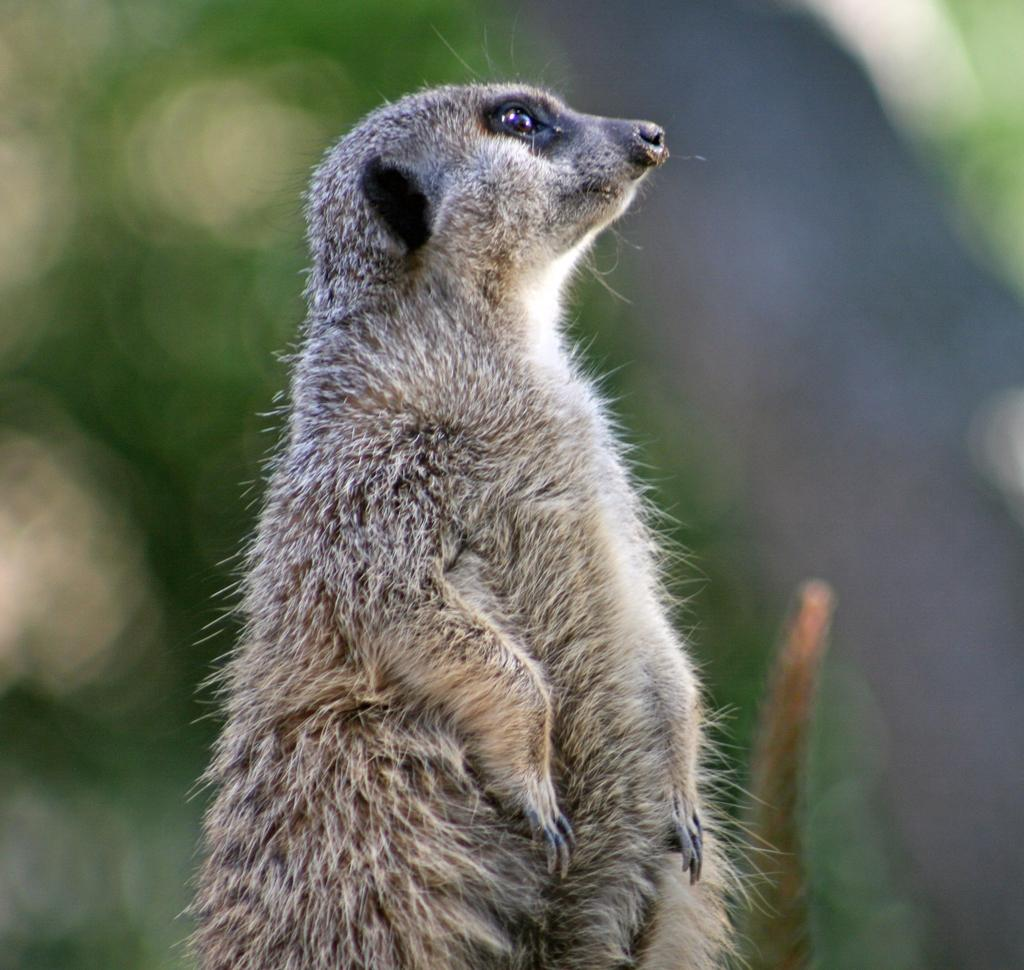What animal is the main subject of the image? There is a Meerkat in the image. Can you describe the background of the image? The background of the image is blurred. What type of thread is being used to sew the Meerkat's tail in the image? There is no thread or sewing activity present in the image; it features a Meerkat with no visible tail. 